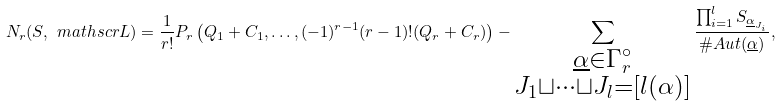<formula> <loc_0><loc_0><loc_500><loc_500>N _ { r } ( S , \ m a t h s c r { L } ) = \frac { 1 } { r ! } P _ { r } \left ( Q _ { 1 } + C _ { 1 } , \dots , ( - 1 ) ^ { r - 1 } ( r - 1 ) ! ( Q _ { r } + C _ { r } ) \right ) - \sum _ { \substack { \underline { \alpha } \in \Gamma _ { r } ^ { \circ } \\ J _ { 1 } \sqcup \dots \sqcup J _ { l } = [ l ( \alpha ) ] } } \frac { \prod _ { i = 1 } ^ { l } S _ { \underline { \alpha } _ { J _ { i } } } } { \# A u t ( \underline { \alpha } ) } ,</formula> 